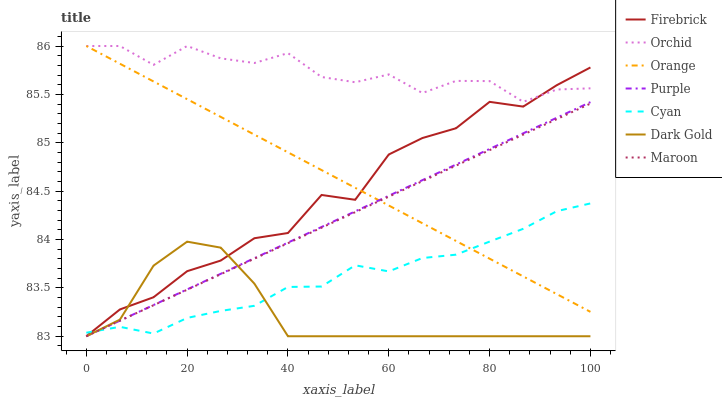Does Dark Gold have the minimum area under the curve?
Answer yes or no. Yes. Does Orchid have the maximum area under the curve?
Answer yes or no. Yes. Does Purple have the minimum area under the curve?
Answer yes or no. No. Does Purple have the maximum area under the curve?
Answer yes or no. No. Is Orange the smoothest?
Answer yes or no. Yes. Is Firebrick the roughest?
Answer yes or no. Yes. Is Purple the smoothest?
Answer yes or no. No. Is Purple the roughest?
Answer yes or no. No. Does Dark Gold have the lowest value?
Answer yes or no. Yes. Does Orange have the lowest value?
Answer yes or no. No. Does Orchid have the highest value?
Answer yes or no. Yes. Does Purple have the highest value?
Answer yes or no. No. Is Cyan less than Orchid?
Answer yes or no. Yes. Is Orchid greater than Purple?
Answer yes or no. Yes. Does Orchid intersect Firebrick?
Answer yes or no. Yes. Is Orchid less than Firebrick?
Answer yes or no. No. Is Orchid greater than Firebrick?
Answer yes or no. No. Does Cyan intersect Orchid?
Answer yes or no. No. 